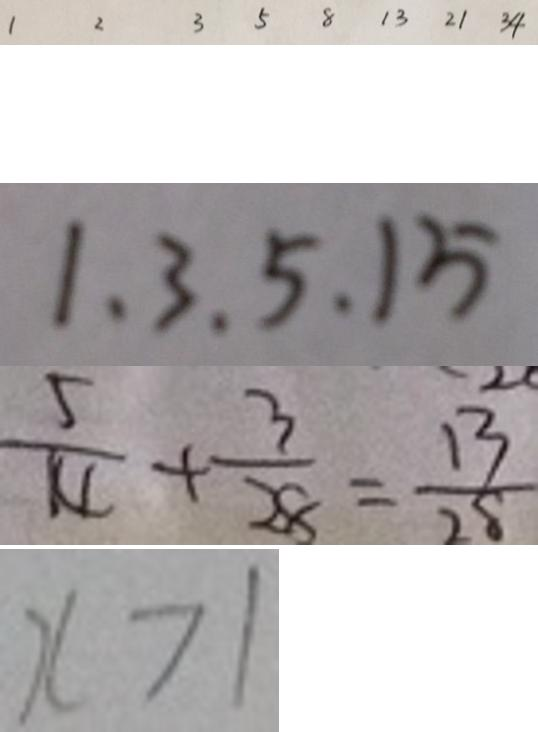<formula> <loc_0><loc_0><loc_500><loc_500>1 2 3 5 8 1 3 2 1 3 4 
 1 . 3 . 5 . 1 5 
 \frac { 5 } { 1 4 } + \frac { 3 } { 2 8 } = \frac { 1 3 } { 2 8 } 
 x > 1</formula> 